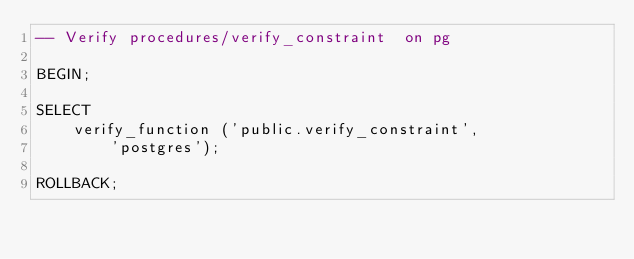Convert code to text. <code><loc_0><loc_0><loc_500><loc_500><_SQL_>-- Verify procedures/verify_constraint  on pg

BEGIN;

SELECT
    verify_function ('public.verify_constraint',
        'postgres');

ROLLBACK;
</code> 